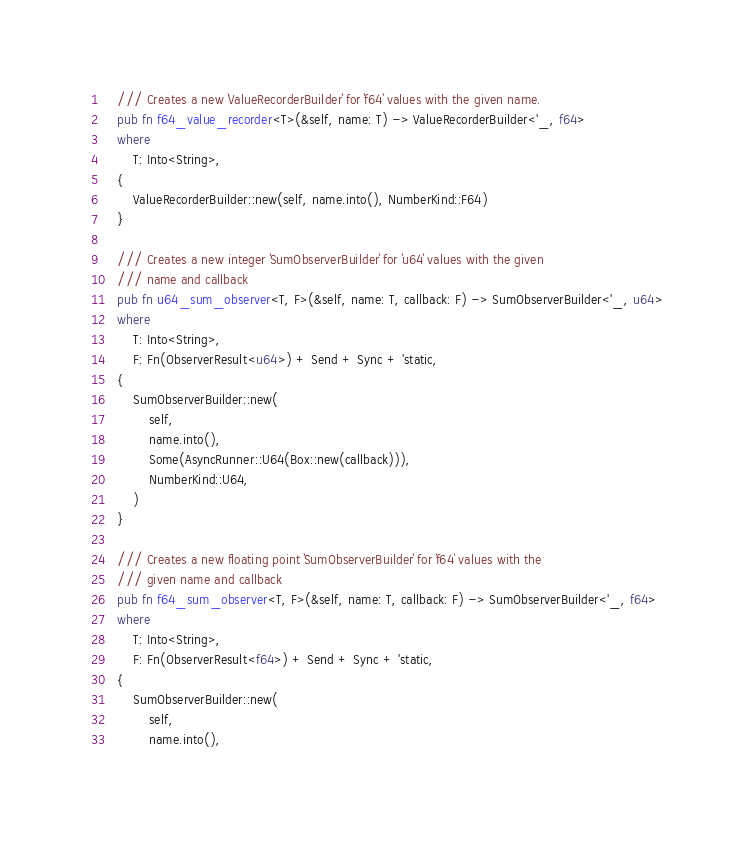<code> <loc_0><loc_0><loc_500><loc_500><_Rust_>    /// Creates a new `ValueRecorderBuilder` for `f64` values with the given name.
    pub fn f64_value_recorder<T>(&self, name: T) -> ValueRecorderBuilder<'_, f64>
    where
        T: Into<String>,
    {
        ValueRecorderBuilder::new(self, name.into(), NumberKind::F64)
    }

    /// Creates a new integer `SumObserverBuilder` for `u64` values with the given
    /// name and callback
    pub fn u64_sum_observer<T, F>(&self, name: T, callback: F) -> SumObserverBuilder<'_, u64>
    where
        T: Into<String>,
        F: Fn(ObserverResult<u64>) + Send + Sync + 'static,
    {
        SumObserverBuilder::new(
            self,
            name.into(),
            Some(AsyncRunner::U64(Box::new(callback))),
            NumberKind::U64,
        )
    }

    /// Creates a new floating point `SumObserverBuilder` for `f64` values with the
    /// given name and callback
    pub fn f64_sum_observer<T, F>(&self, name: T, callback: F) -> SumObserverBuilder<'_, f64>
    where
        T: Into<String>,
        F: Fn(ObserverResult<f64>) + Send + Sync + 'static,
    {
        SumObserverBuilder::new(
            self,
            name.into(),</code> 